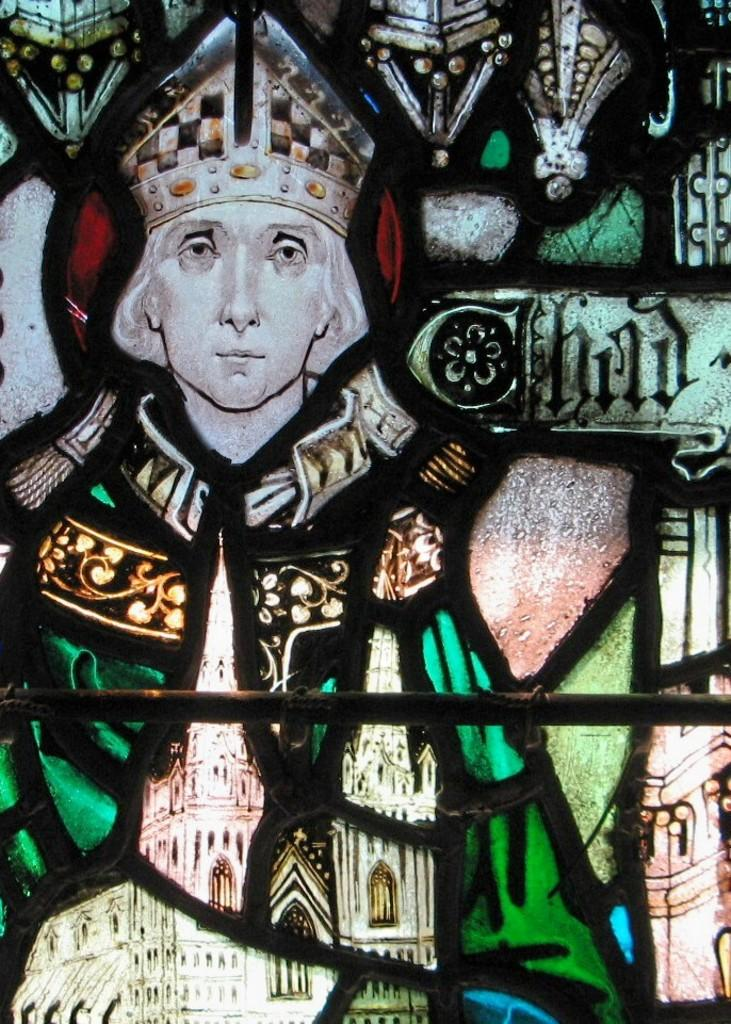What is the main subject of the image? There is a painting in the image. What can be seen in the painting? The painting contains a person and buildings. Are there any other elements in the painting besides the person and buildings? Yes, the painting contains other unspecified elements. How many bikes are parked in front of the buildings in the painting? There is no information about bikes in the painting, as the provided facts only mention a person and buildings. 